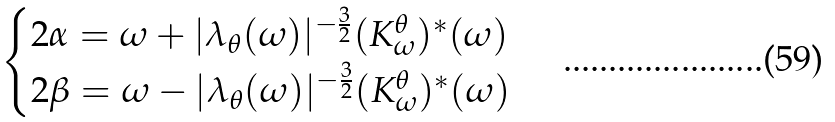<formula> <loc_0><loc_0><loc_500><loc_500>\begin{cases} 2 \alpha = \omega + | \lambda _ { \theta } ( \omega ) | ^ { - \frac { 3 } { 2 } } ( K _ { \omega } ^ { \theta } ) ^ { * } ( \omega ) & \\ 2 \beta = \omega - | \lambda _ { \theta } ( \omega ) | ^ { - \frac { 3 } { 2 } } ( K _ { \omega } ^ { \theta } ) ^ { * } ( \omega ) & \\ \end{cases}</formula> 